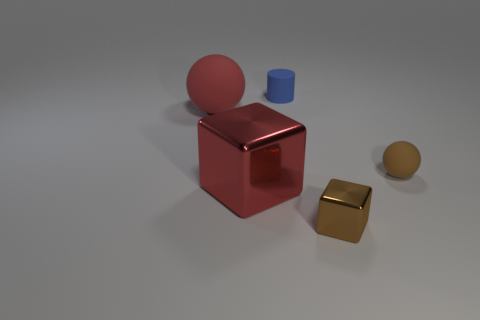What is the color of the small sphere? The small sphere in the image has a gold hue, complementing the light it reflects. 